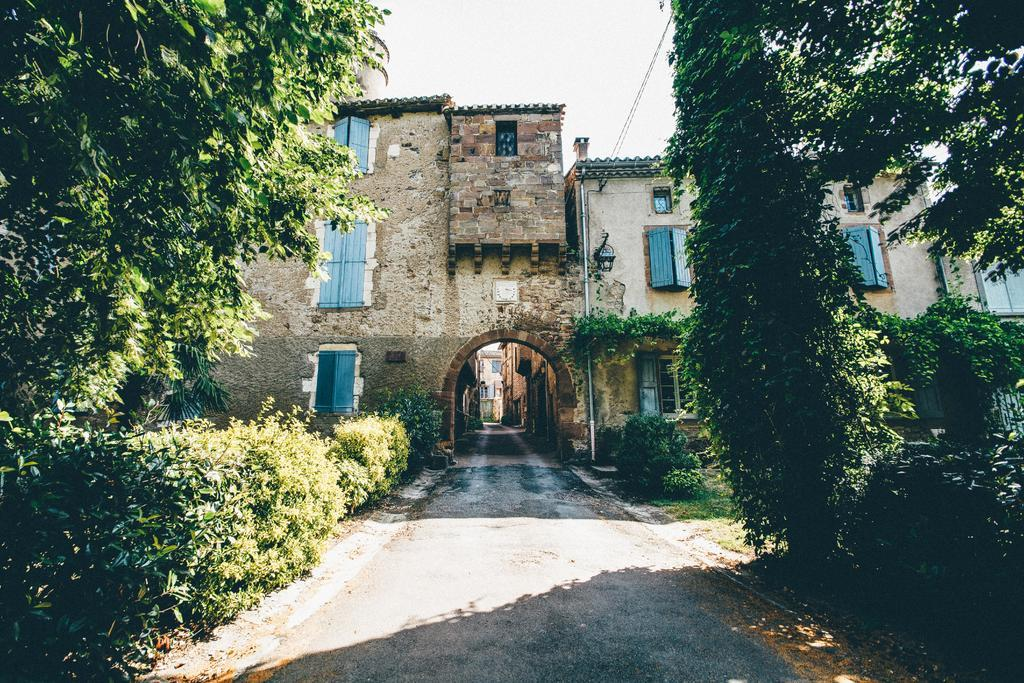What type of structures can be seen in the image? There are buildings in the image. What natural elements are present in the image? There are trees and plants in the image. What architectural features can be observed in the image? There are windows, wires, a pole, and a light in the image. What is visible in the background of the image? The sky is visible in the background of the image. What type of notebook is being used by the animal in the image? There is no animal or notebook present in the image. How often does the light need to be washed in the image? The image does not provide information about the frequency of washing the light, as it is a static representation. 